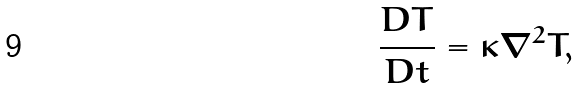<formula> <loc_0><loc_0><loc_500><loc_500>\frac { D T } { D t } = \kappa \nabla ^ { 2 } T ,</formula> 